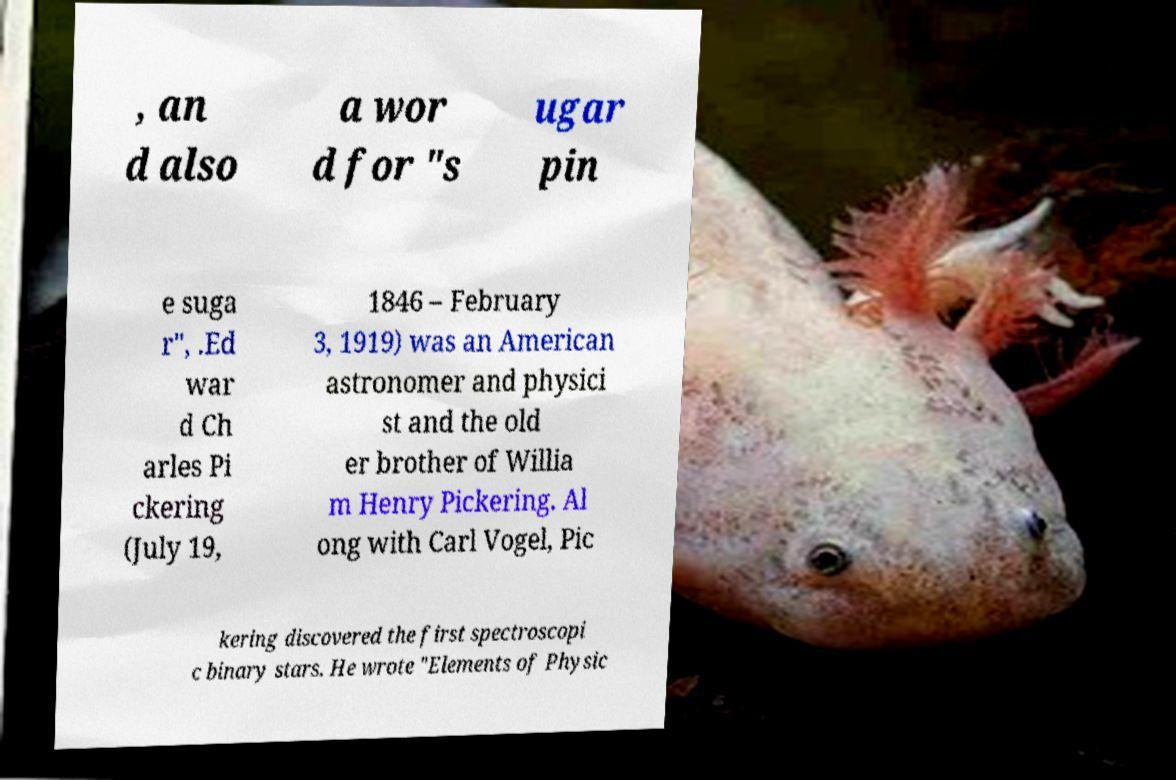Can you read and provide the text displayed in the image?This photo seems to have some interesting text. Can you extract and type it out for me? , an d also a wor d for "s ugar pin e suga r", .Ed war d Ch arles Pi ckering (July 19, 1846 – February 3, 1919) was an American astronomer and physici st and the old er brother of Willia m Henry Pickering. Al ong with Carl Vogel, Pic kering discovered the first spectroscopi c binary stars. He wrote "Elements of Physic 